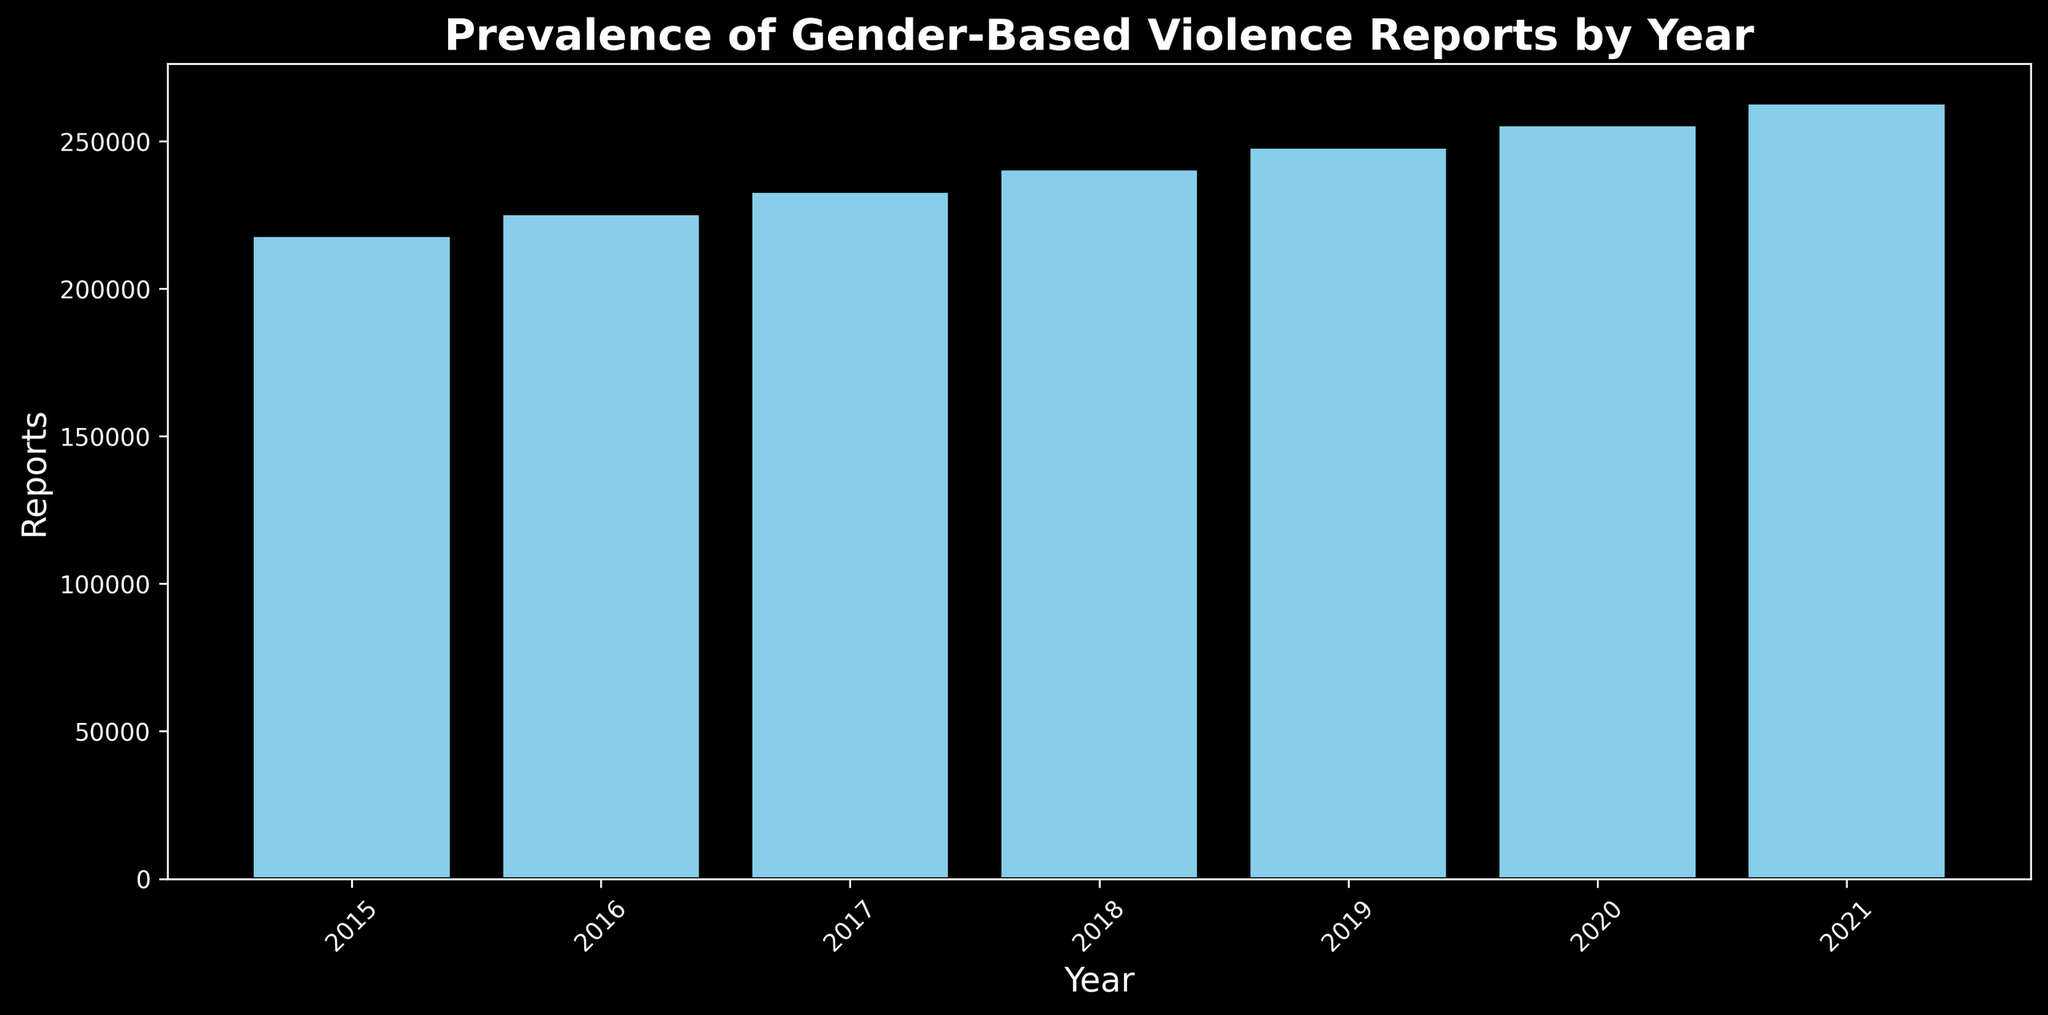How does the total number of gender-based violence reports in 2017 compare to that in 2020? To answer this, look at the heights of the bars for the year 2017 and 2020. The bar for 2020 is higher than that for 2017, indicating more reports in 2020.
Answer: 2020 has more reports than 2017 What is the trend in the number of reports from 2015 to 2021? Observe the overall direction of the bars from 2015 to 2021. The bars consistently increase in height, indicating a rising trend in the number of reports.
Answer: Increasing Which year had the highest number of gender-based violence reports? Identify the tallest bar on the plot. The tallest bar corresponds to the year 2021.
Answer: 2021 By how much did the reports increase from 2015 to 2021? Identify the height of bars for 2015 and 2021. Subtract the height for 2015 from that for 2021. The bar for 2021 is higher by 130,000 - 138,000 (350,000 - 220,000).
Answer: 130,000 Which year saw the smallest increase in the number of reports compared to the previous year? Examine the differences in bar heights year-on-year. The smallest increase appears between 2019 and 2020, an increase of about 30,000 reports (sum of smaller  increase between successive years).
Answer: 2019-2020 What is the average number of reports per year over the given period? Sum the total reports from all years and divide by the number of years (7). The total is 2,380,000; the average is 2,380,000 / 7 = 340,000.
Answer: 340,000 What was the approximate total number of reports in the year 2016? Check the bar for 2016 on the plot, which is approximately 280,000 reports.
Answer: 280,000 Are there any years that had an equal number of reports? Ensure that bars for different years are all different heights. No bars have the same height, indicating no years with equal numbers of reports.
Answer: No What is the percentage increase in the number of reports from 2018 to 2021? Calculate the difference between values for 2018 and 2021, then divide by the 2018 value and multiply by 100. (310,000 - 285,000) / 285,000 * 100 ≈ 8.77%.
Answer: 8.77% How does the increase in reports from 2016 to 2017 compare to the increase from 2017 to 2018? Observe the relative differences in bar heights between these consecutive years. The increase is approximately 20,000 from 2016 to 2017 and the same from 2017 to 2018.
Answer: The increases are equal 